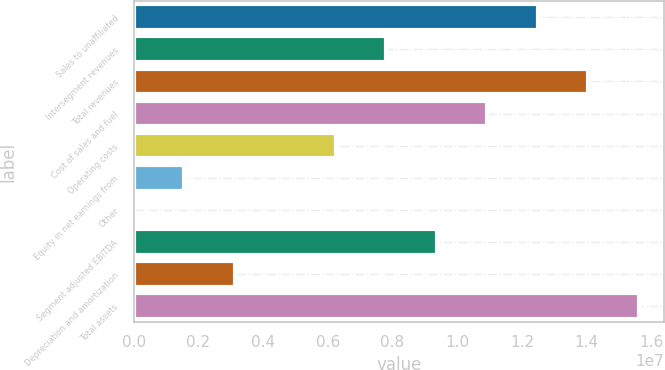Convert chart. <chart><loc_0><loc_0><loc_500><loc_500><bar_chart><fcel>Sales to unaffiliated<fcel>Intersegment revenues<fcel>Total revenues<fcel>Cost of sales and fuel<fcel>Operating costs<fcel>Equity in net earnings from<fcel>Other<fcel>Segment adjusted EBITDA<fcel>Depreciation and amortization<fcel>Total assets<nl><fcel>1.24921e+07<fcel>7.80789e+06<fcel>1.40535e+07<fcel>1.09307e+07<fcel>6.24648e+06<fcel>1.56225e+06<fcel>841<fcel>9.3693e+06<fcel>3.12366e+06<fcel>1.56149e+07<nl></chart> 